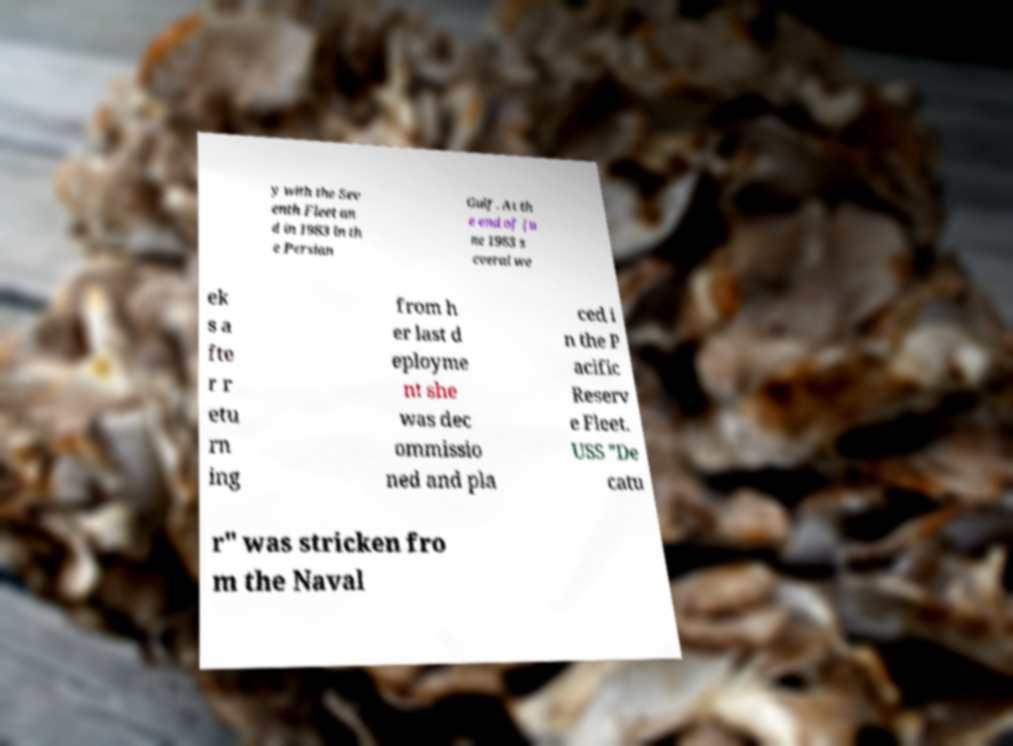Can you read and provide the text displayed in the image?This photo seems to have some interesting text. Can you extract and type it out for me? y with the Sev enth Fleet an d in 1983 in th e Persian Gulf. At th e end of Ju ne 1983 s everal we ek s a fte r r etu rn ing from h er last d eployme nt she was dec ommissio ned and pla ced i n the P acific Reserv e Fleet. USS "De catu r" was stricken fro m the Naval 